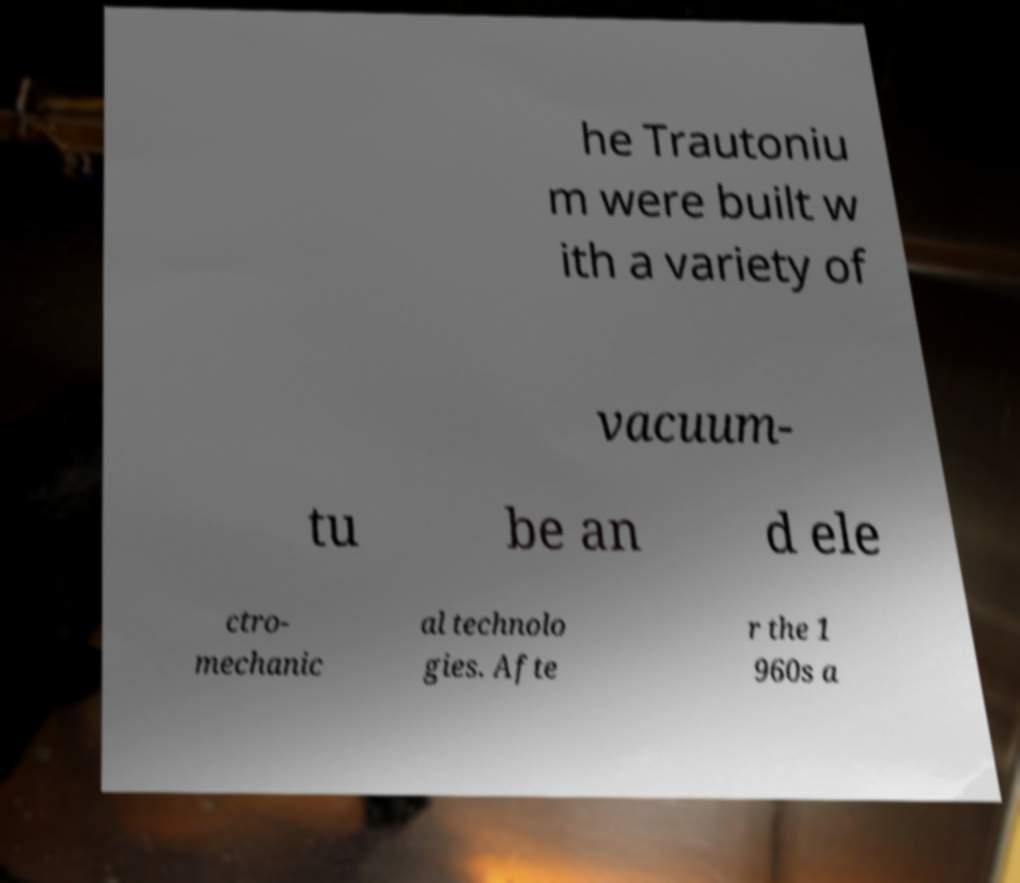I need the written content from this picture converted into text. Can you do that? he Trautoniu m were built w ith a variety of vacuum- tu be an d ele ctro- mechanic al technolo gies. Afte r the 1 960s a 